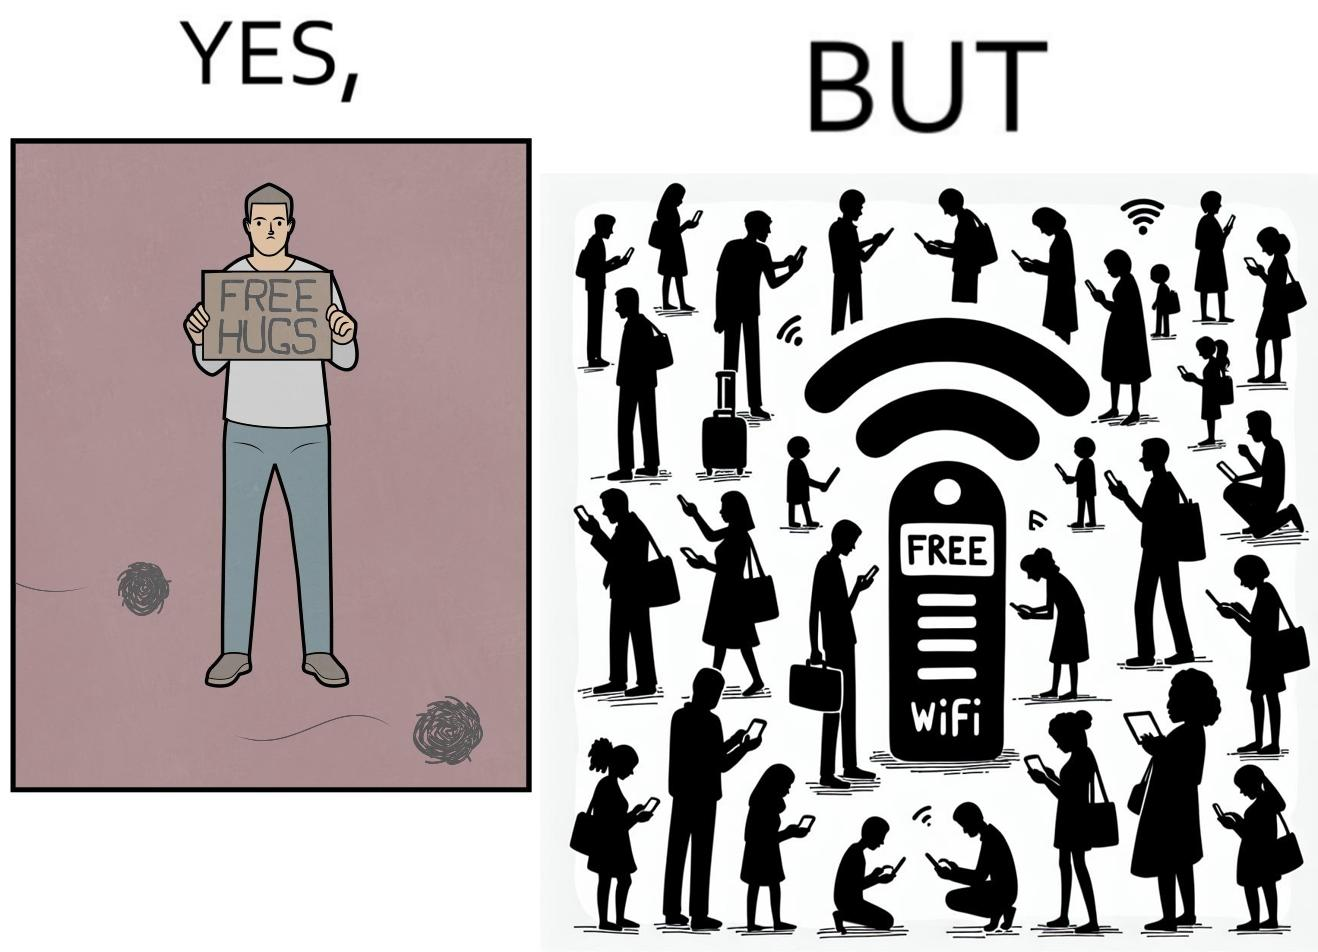Is this image satirical or non-satirical? Yes, this image is satirical. 